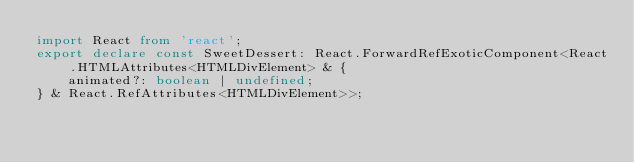<code> <loc_0><loc_0><loc_500><loc_500><_TypeScript_>import React from 'react';
export declare const SweetDessert: React.ForwardRefExoticComponent<React.HTMLAttributes<HTMLDivElement> & {
    animated?: boolean | undefined;
} & React.RefAttributes<HTMLDivElement>>;
</code> 